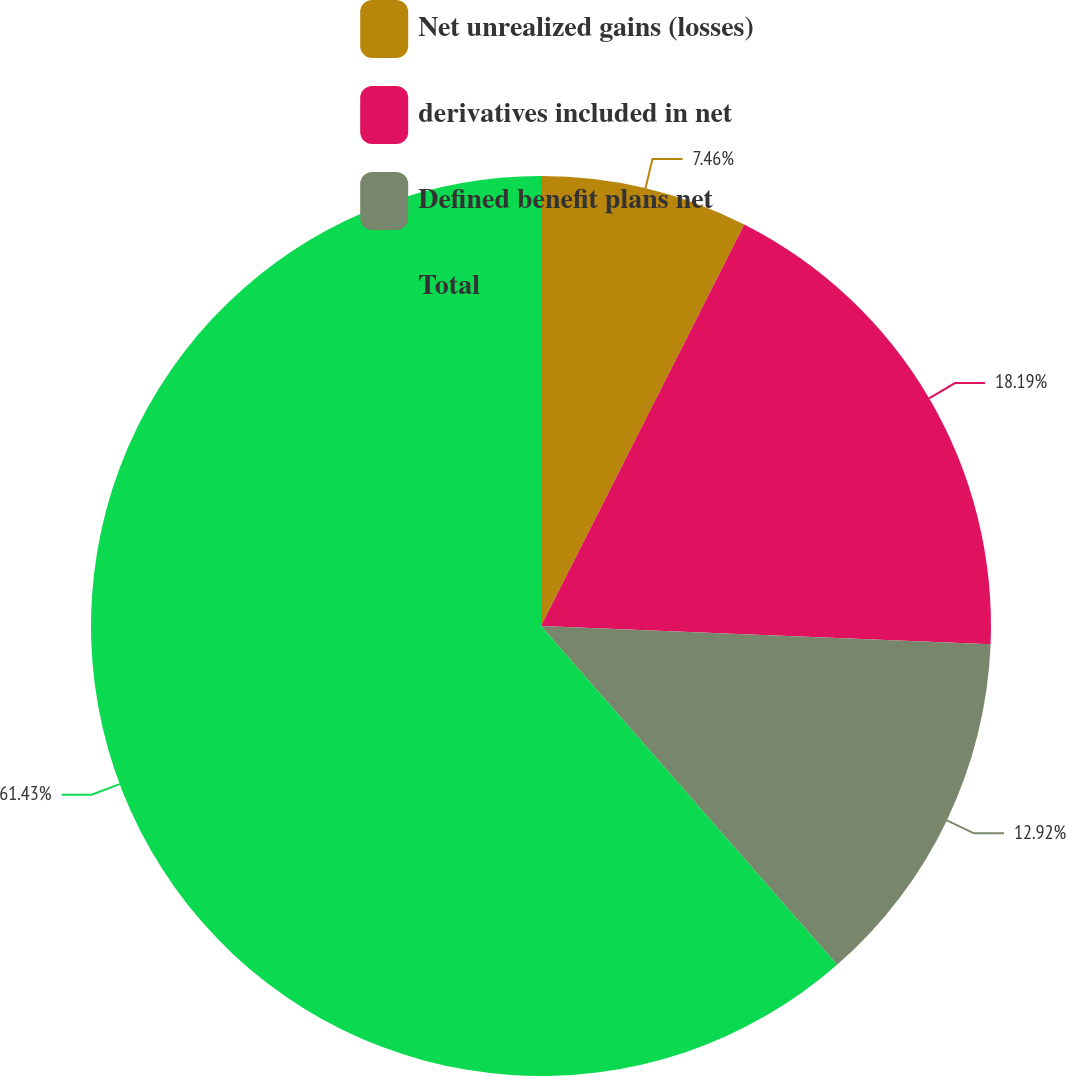Convert chart. <chart><loc_0><loc_0><loc_500><loc_500><pie_chart><fcel>Net unrealized gains (losses)<fcel>derivatives included in net<fcel>Defined benefit plans net<fcel>Total<nl><fcel>7.46%<fcel>18.19%<fcel>12.92%<fcel>61.43%<nl></chart> 